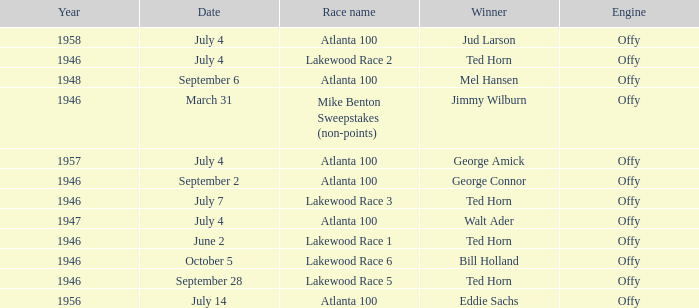Which race did Bill Holland win in 1946? Lakewood Race 6. Can you parse all the data within this table? {'header': ['Year', 'Date', 'Race name', 'Winner', 'Engine'], 'rows': [['1958', 'July 4', 'Atlanta 100', 'Jud Larson', 'Offy'], ['1946', 'July 4', 'Lakewood Race 2', 'Ted Horn', 'Offy'], ['1948', 'September 6', 'Atlanta 100', 'Mel Hansen', 'Offy'], ['1946', 'March 31', 'Mike Benton Sweepstakes (non-points)', 'Jimmy Wilburn', 'Offy'], ['1957', 'July 4', 'Atlanta 100', 'George Amick', 'Offy'], ['1946', 'September 2', 'Atlanta 100', 'George Connor', 'Offy'], ['1946', 'July 7', 'Lakewood Race 3', 'Ted Horn', 'Offy'], ['1947', 'July 4', 'Atlanta 100', 'Walt Ader', 'Offy'], ['1946', 'June 2', 'Lakewood Race 1', 'Ted Horn', 'Offy'], ['1946', 'October 5', 'Lakewood Race 6', 'Bill Holland', 'Offy'], ['1946', 'September 28', 'Lakewood Race 5', 'Ted Horn', 'Offy'], ['1956', 'July 14', 'Atlanta 100', 'Eddie Sachs', 'Offy']]} 